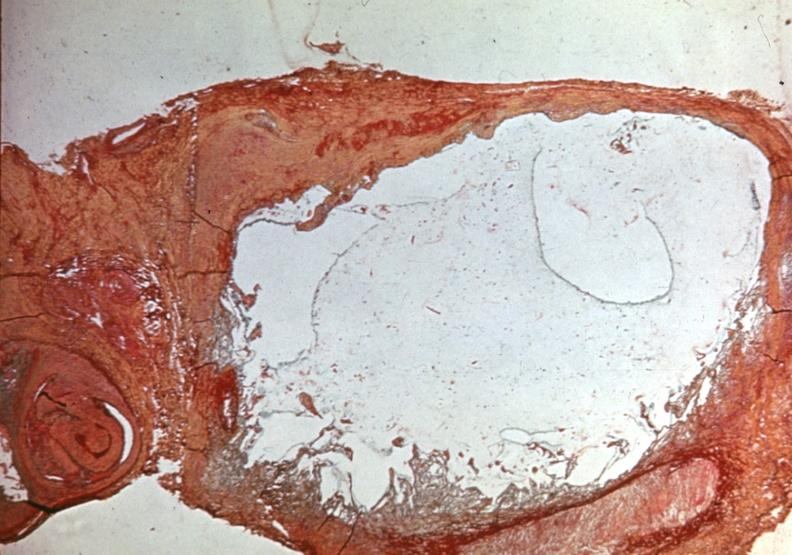what is present?
Answer the question using a single word or phrase. Joints 